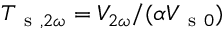Convert formula to latex. <formula><loc_0><loc_0><loc_500><loc_500>T _ { s , 2 \omega } = V _ { 2 \omega } / ( \alpha V _ { s 0 } )</formula> 